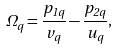<formula> <loc_0><loc_0><loc_500><loc_500>\Omega _ { q } = \frac { p _ { 1 q } } { v _ { q } } - \frac { p _ { 2 q } } { u _ { q } } ,</formula> 